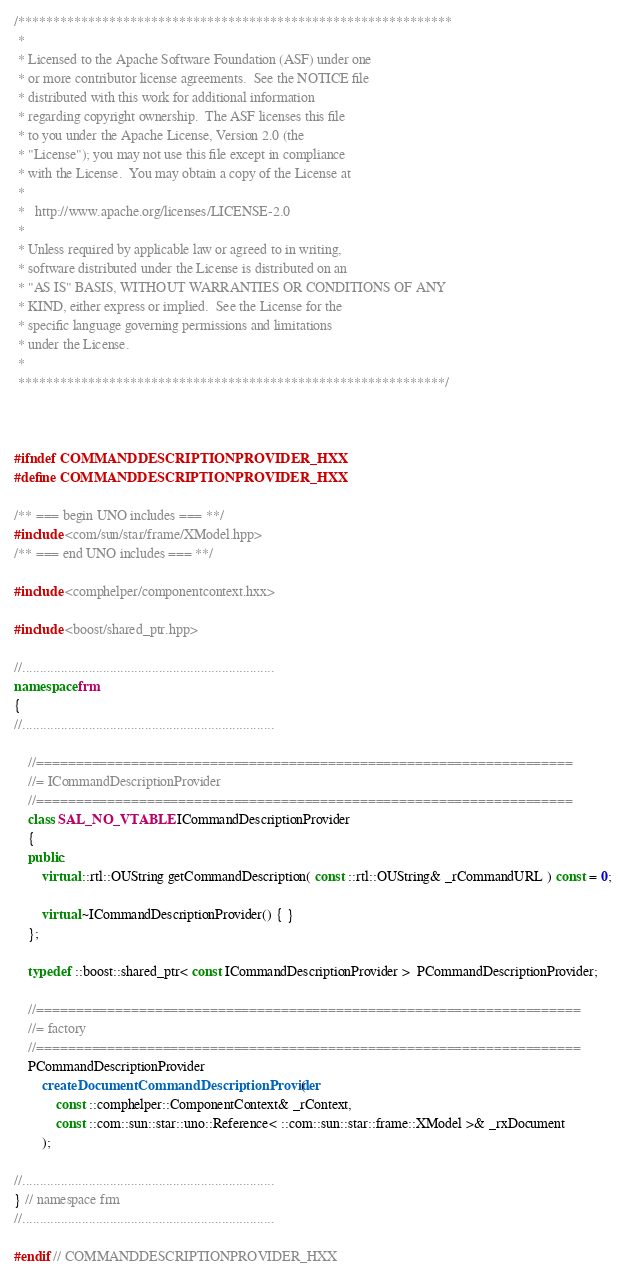Convert code to text. <code><loc_0><loc_0><loc_500><loc_500><_C++_>/**************************************************************
 * 
 * Licensed to the Apache Software Foundation (ASF) under one
 * or more contributor license agreements.  See the NOTICE file
 * distributed with this work for additional information
 * regarding copyright ownership.  The ASF licenses this file
 * to you under the Apache License, Version 2.0 (the
 * "License"); you may not use this file except in compliance
 * with the License.  You may obtain a copy of the License at
 * 
 *   http://www.apache.org/licenses/LICENSE-2.0
 * 
 * Unless required by applicable law or agreed to in writing,
 * software distributed under the License is distributed on an
 * "AS IS" BASIS, WITHOUT WARRANTIES OR CONDITIONS OF ANY
 * KIND, either express or implied.  See the License for the
 * specific language governing permissions and limitations
 * under the License.
 * 
 *************************************************************/



#ifndef COMMANDDESCRIPTIONPROVIDER_HXX
#define COMMANDDESCRIPTIONPROVIDER_HXX

/** === begin UNO includes === **/
#include <com/sun/star/frame/XModel.hpp>
/** === end UNO includes === **/

#include <comphelper/componentcontext.hxx>

#include <boost/shared_ptr.hpp>

//........................................................................
namespace frm
{
//........................................................................

	//====================================================================
	//= ICommandDescriptionProvider
	//====================================================================
	class SAL_NO_VTABLE ICommandDescriptionProvider
	{
    public:
        virtual ::rtl::OUString getCommandDescription( const ::rtl::OUString& _rCommandURL ) const = 0;

        virtual ~ICommandDescriptionProvider() { }
	};

    typedef ::boost::shared_ptr< const ICommandDescriptionProvider >  PCommandDescriptionProvider;

    //=====================================================================
    //= factory
    //=====================================================================
    PCommandDescriptionProvider
        createDocumentCommandDescriptionProvider(
            const ::comphelper::ComponentContext& _rContext,
            const ::com::sun::star::uno::Reference< ::com::sun::star::frame::XModel >& _rxDocument
        );

//........................................................................
} // namespace frm
//........................................................................

#endif // COMMANDDESCRIPTIONPROVIDER_HXX
</code> 